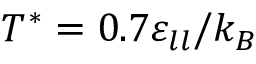Convert formula to latex. <formula><loc_0><loc_0><loc_500><loc_500>T ^ { * } = 0 . 7 \varepsilon _ { l l } / k _ { B }</formula> 